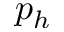Convert formula to latex. <formula><loc_0><loc_0><loc_500><loc_500>p _ { h }</formula> 